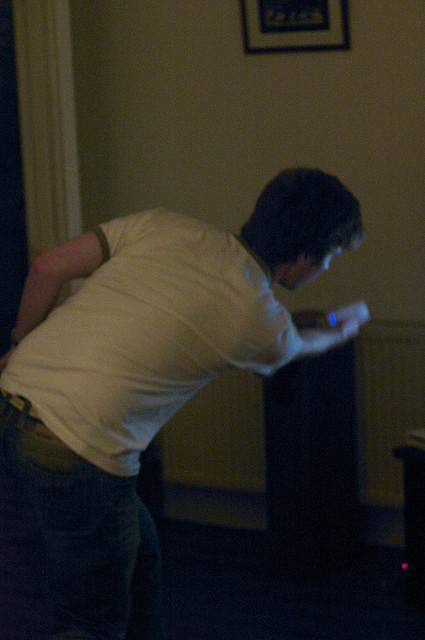What activity is he participating in?
Keep it brief. Wii. What color is his shirt?
Give a very brief answer. White. Are people meant to skateboard in this location?
Write a very short answer. No. How many men are in the picture?
Concise answer only. 1. What is this person holding?
Answer briefly. Controller. What is he looking at?
Write a very short answer. Tv. What is this person standing on?
Concise answer only. Floor. Can you see a man's stomach?
Be succinct. No. What are the main colors in this photo?
Quick response, please. White. What is in the hand?
Short answer required. Wii remote. Where is the electrical outlet?
Concise answer only. Wall. What is the person leaning on?
Give a very brief answer. Nothing. What color is the wall?
Give a very brief answer. White. What is the man doing?
Write a very short answer. Playing wii. What is the boy holding?
Give a very brief answer. Wii remote. Is this a restaurant?
Concise answer only. No. What competition is this?
Concise answer only. Wii. Is the boy riding a skateboard?
Keep it brief. No. Is this man wearing a t shirt?
Be succinct. Yes. What color is the man's shirt?
Keep it brief. White. What gesture is the person making with his right hand?
Quick response, please. Pointing. What kind of appliance is on the stand?
Keep it brief. Tv. 